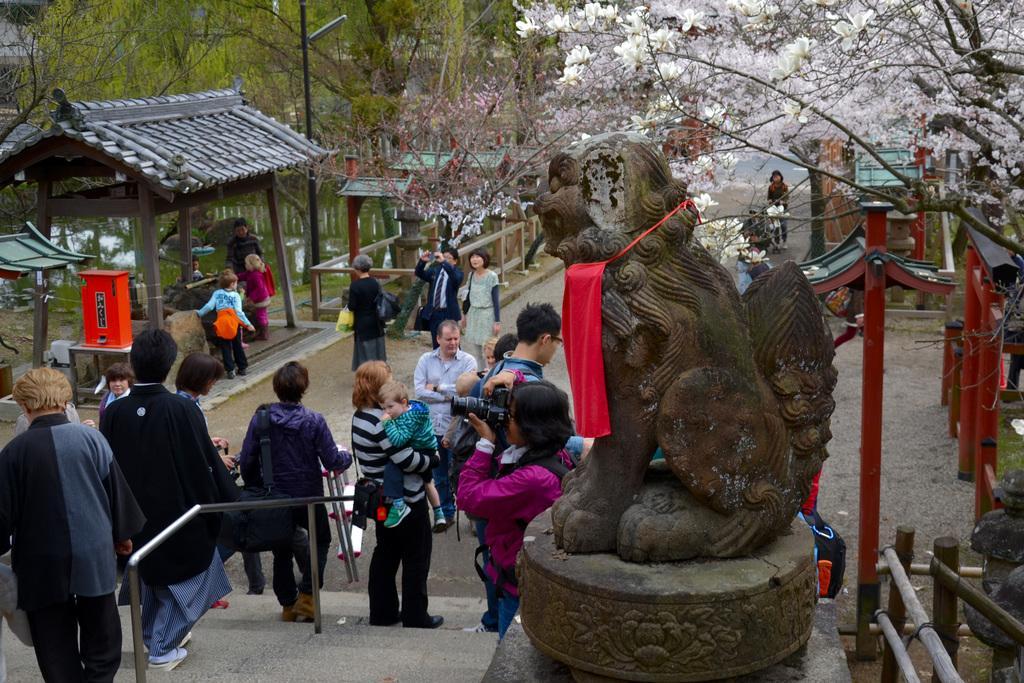How would you summarize this image in a sentence or two? In this picture I can see there is a statue at right side and there are stairs, few people on the stairs, there is a railing. There are few trees in the backdrop and there is a lake at left side and there are a few people standing at the backdrop. 